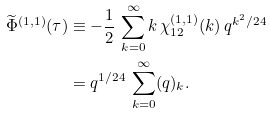<formula> <loc_0><loc_0><loc_500><loc_500>\widetilde { \Phi } ^ { ( 1 , 1 ) } ( \tau ) & \equiv - \frac { 1 } { 2 } \, \sum _ { k = 0 } ^ { \infty } k \, \chi _ { 1 2 } ^ { ( 1 , 1 ) } ( k ) \, q ^ { k ^ { 2 } / 2 4 } \\ & = q ^ { 1 / 2 4 } \, \sum _ { k = 0 } ^ { \infty } ( q ) _ { k } .</formula> 